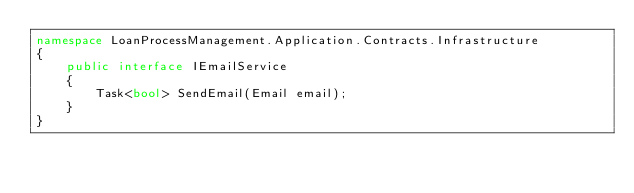Convert code to text. <code><loc_0><loc_0><loc_500><loc_500><_C#_>namespace LoanProcessManagement.Application.Contracts.Infrastructure
{
    public interface IEmailService
    {
        Task<bool> SendEmail(Email email);
    }
}
</code> 